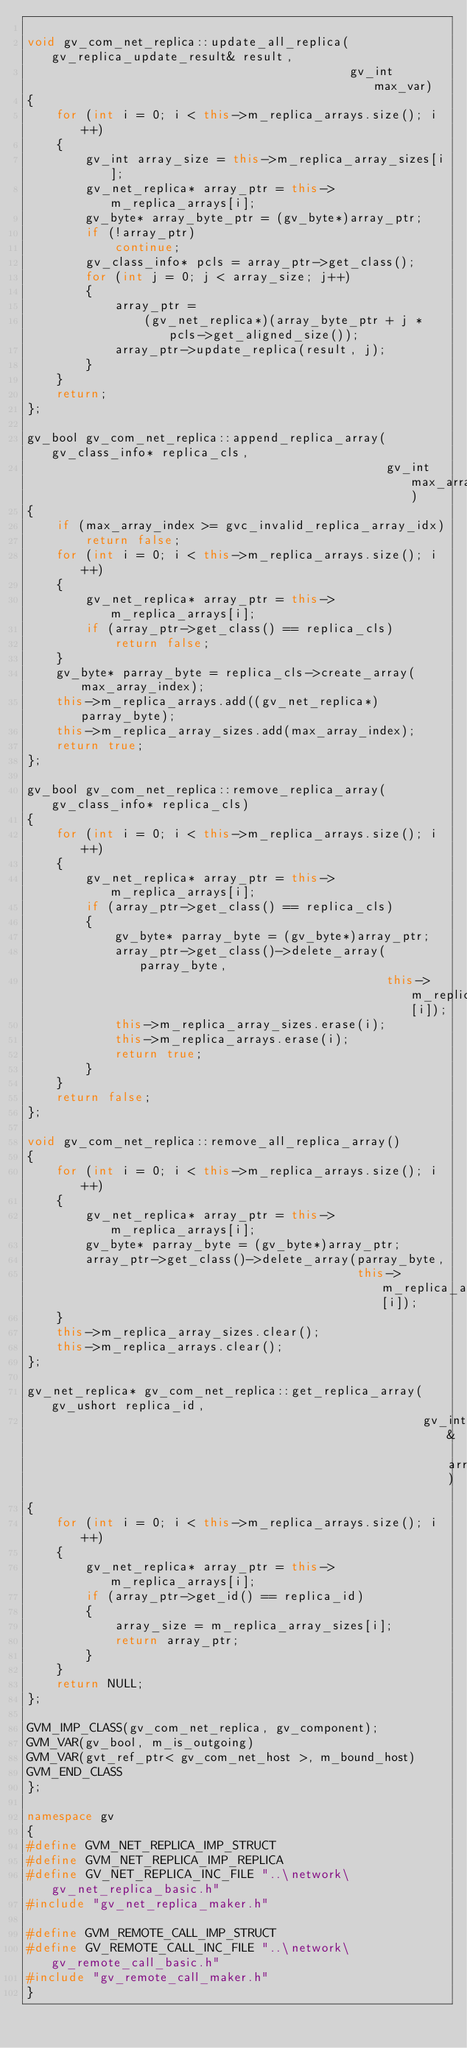Convert code to text. <code><loc_0><loc_0><loc_500><loc_500><_C++_>
void gv_com_net_replica::update_all_replica(gv_replica_update_result& result,
											gv_int max_var)
{
	for (int i = 0; i < this->m_replica_arrays.size(); i++)
	{
		gv_int array_size = this->m_replica_array_sizes[i];
		gv_net_replica* array_ptr = this->m_replica_arrays[i];
		gv_byte* array_byte_ptr = (gv_byte*)array_ptr;
		if (!array_ptr)
			continue;
		gv_class_info* pcls = array_ptr->get_class();
		for (int j = 0; j < array_size; j++)
		{
			array_ptr =
				(gv_net_replica*)(array_byte_ptr + j * pcls->get_aligned_size());
			array_ptr->update_replica(result, j);
		}
	}
	return;
};

gv_bool gv_com_net_replica::append_replica_array(gv_class_info* replica_cls,
												 gv_int max_array_index)
{
	if (max_array_index >= gvc_invalid_replica_array_idx)
		return false;
	for (int i = 0; i < this->m_replica_arrays.size(); i++)
	{
		gv_net_replica* array_ptr = this->m_replica_arrays[i];
		if (array_ptr->get_class() == replica_cls)
			return false;
	}
	gv_byte* parray_byte = replica_cls->create_array(max_array_index);
	this->m_replica_arrays.add((gv_net_replica*)parray_byte);
	this->m_replica_array_sizes.add(max_array_index);
	return true;
};

gv_bool gv_com_net_replica::remove_replica_array(gv_class_info* replica_cls)
{
	for (int i = 0; i < this->m_replica_arrays.size(); i++)
	{
		gv_net_replica* array_ptr = this->m_replica_arrays[i];
		if (array_ptr->get_class() == replica_cls)
		{
			gv_byte* parray_byte = (gv_byte*)array_ptr;
			array_ptr->get_class()->delete_array(parray_byte,
												 this->m_replica_array_sizes[i]);
			this->m_replica_array_sizes.erase(i);
			this->m_replica_arrays.erase(i);
			return true;
		}
	}
	return false;
};

void gv_com_net_replica::remove_all_replica_array()
{
	for (int i = 0; i < this->m_replica_arrays.size(); i++)
	{
		gv_net_replica* array_ptr = this->m_replica_arrays[i];
		gv_byte* parray_byte = (gv_byte*)array_ptr;
		array_ptr->get_class()->delete_array(parray_byte,
											 this->m_replica_array_sizes[i]);
	}
	this->m_replica_array_sizes.clear();
	this->m_replica_arrays.clear();
};

gv_net_replica* gv_com_net_replica::get_replica_array(gv_ushort replica_id,
													  gv_int& array_size)
{
	for (int i = 0; i < this->m_replica_arrays.size(); i++)
	{
		gv_net_replica* array_ptr = this->m_replica_arrays[i];
		if (array_ptr->get_id() == replica_id)
		{
			array_size = m_replica_array_sizes[i];
			return array_ptr;
		}
	}
	return NULL;
};

GVM_IMP_CLASS(gv_com_net_replica, gv_component);
GVM_VAR(gv_bool, m_is_outgoing)
GVM_VAR(gvt_ref_ptr< gv_com_net_host >, m_bound_host)
GVM_END_CLASS
};

namespace gv
{
#define GVM_NET_REPLICA_IMP_STRUCT
#define GVM_NET_REPLICA_IMP_REPLICA
#define GV_NET_REPLICA_INC_FILE "..\network\gv_net_replica_basic.h"
#include "gv_net_replica_maker.h"

#define GVM_REMOTE_CALL_IMP_STRUCT
#define GV_REMOTE_CALL_INC_FILE "..\network\gv_remote_call_basic.h"
#include "gv_remote_call_maker.h"
}</code> 